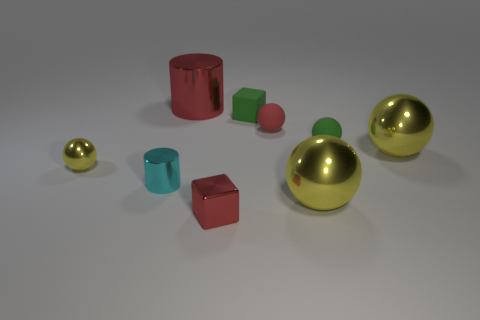Is the number of red things to the right of the large red thing greater than the number of green spheres?
Your answer should be compact. Yes. How many metallic blocks are the same size as the cyan metallic thing?
Offer a very short reply. 1. Do the green rubber thing in front of the small matte block and the metal thing behind the red matte sphere have the same size?
Provide a succinct answer. No. Is the number of yellow metal spheres that are right of the big red metal thing greater than the number of cylinders right of the red matte sphere?
Provide a succinct answer. Yes. What number of other tiny metallic things are the same shape as the small yellow shiny thing?
Give a very brief answer. 0. There is a yellow object that is the same size as the rubber block; what is it made of?
Ensure brevity in your answer.  Metal. Are there any small green blocks that have the same material as the red ball?
Give a very brief answer. Yes. Are there fewer red metallic cylinders that are on the left side of the cyan object than large yellow matte cubes?
Provide a short and direct response. No. The small green object left of the big sphere that is in front of the tiny yellow thing is made of what material?
Your response must be concise. Rubber. What shape is the red thing that is both in front of the small green matte block and to the left of the red rubber ball?
Provide a succinct answer. Cube. 